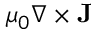<formula> <loc_0><loc_0><loc_500><loc_500>\mu _ { 0 } \nabla \times { \mathbf J }</formula> 